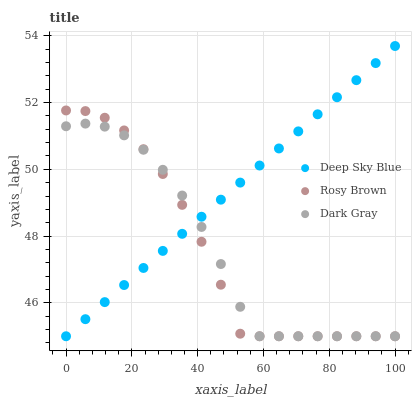Does Rosy Brown have the minimum area under the curve?
Answer yes or no. Yes. Does Deep Sky Blue have the maximum area under the curve?
Answer yes or no. Yes. Does Deep Sky Blue have the minimum area under the curve?
Answer yes or no. No. Does Rosy Brown have the maximum area under the curve?
Answer yes or no. No. Is Deep Sky Blue the smoothest?
Answer yes or no. Yes. Is Rosy Brown the roughest?
Answer yes or no. Yes. Is Rosy Brown the smoothest?
Answer yes or no. No. Is Deep Sky Blue the roughest?
Answer yes or no. No. Does Dark Gray have the lowest value?
Answer yes or no. Yes. Does Deep Sky Blue have the highest value?
Answer yes or no. Yes. Does Rosy Brown have the highest value?
Answer yes or no. No. Does Deep Sky Blue intersect Dark Gray?
Answer yes or no. Yes. Is Deep Sky Blue less than Dark Gray?
Answer yes or no. No. Is Deep Sky Blue greater than Dark Gray?
Answer yes or no. No. 